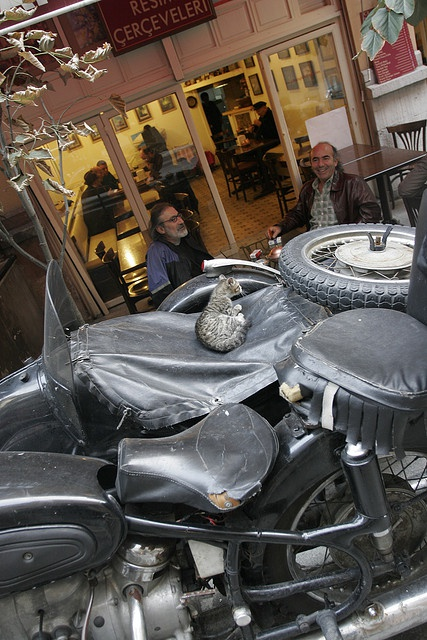Describe the objects in this image and their specific colors. I can see motorcycle in lightgray, black, gray, and darkgray tones, motorcycle in lightgray, darkgray, gray, and black tones, people in lightgray, black, gray, and maroon tones, people in lightgray, black, gray, and maroon tones, and dining table in lightgray, gray, black, and maroon tones in this image. 